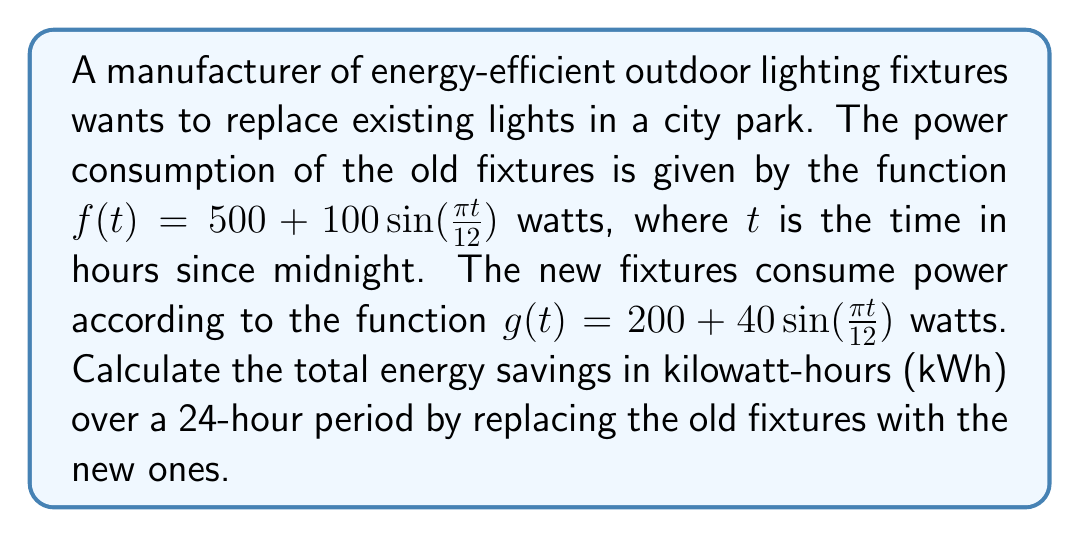Can you solve this math problem? 1) To find the energy savings, we need to calculate the difference in energy consumption between the old and new fixtures over 24 hours.

2) Energy consumption is the integral of power over time. For each function, we need to integrate over the 24-hour period:

   $E = \int_0^{24} P(t) dt$

3) For the old fixtures:
   $E_{old} = \int_0^{24} [500 + 100\sin(\frac{\pi t}{12})] dt$
   $= [500t - \frac{1200}{\pi}\cos(\frac{\pi t}{12})]_0^{24}$
   $= 12000 - \frac{1200}{\pi}[\cos(2\pi) - \cos(0)]$
   $= 12000$ watt-hours

4) For the new fixtures:
   $E_{new} = \int_0^{24} [200 + 40\sin(\frac{\pi t}{12})] dt$
   $= [200t - \frac{480}{\pi}\cos(\frac{\pi t}{12})]_0^{24}$
   $= 4800 - \frac{480}{\pi}[\cos(2\pi) - \cos(0)]$
   $= 4800$ watt-hours

5) The energy savings is the difference:
   $E_{savings} = E_{old} - E_{new} = 12000 - 4800 = 7200$ watt-hours

6) Convert to kilowatt-hours:
   $7200 \text{ watt-hours} = 7.2 \text{ kilowatt-hours}$
Answer: 7.2 kWh 